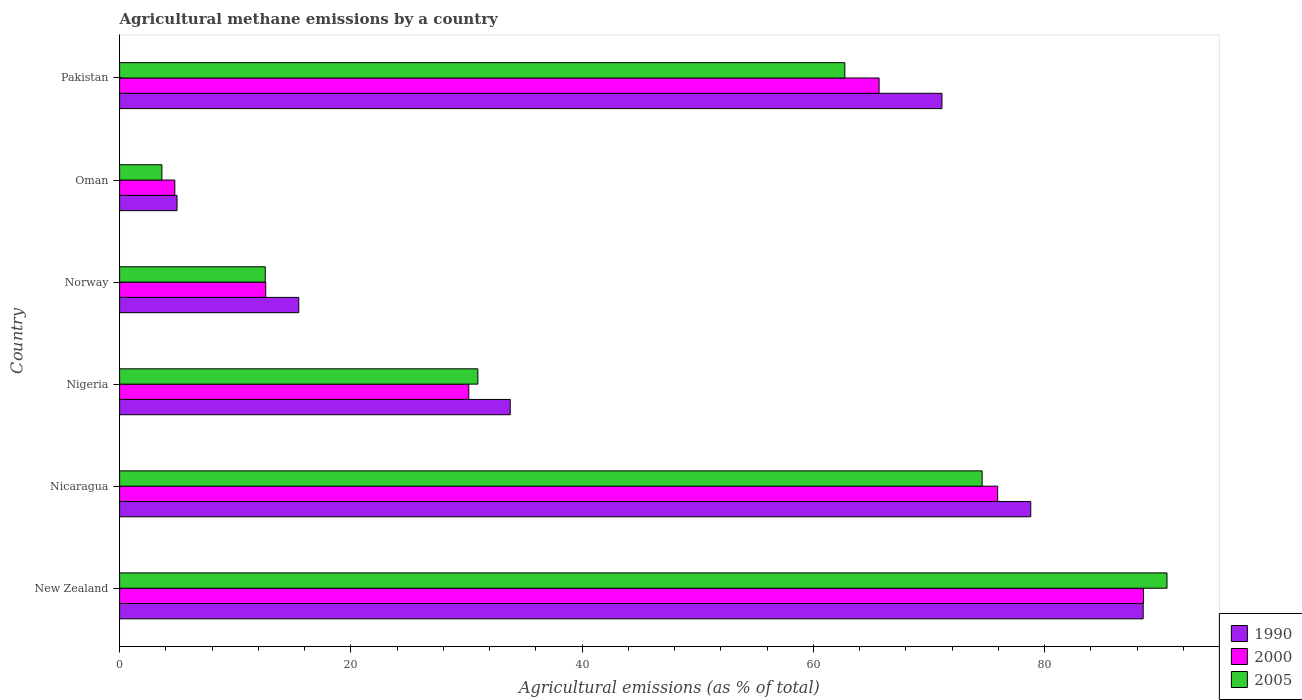How many groups of bars are there?
Offer a very short reply. 6. How many bars are there on the 4th tick from the top?
Give a very brief answer. 3. How many bars are there on the 2nd tick from the bottom?
Provide a succinct answer. 3. What is the label of the 5th group of bars from the top?
Your answer should be very brief. Nicaragua. What is the amount of agricultural methane emitted in 2005 in Oman?
Make the answer very short. 3.66. Across all countries, what is the maximum amount of agricultural methane emitted in 2005?
Make the answer very short. 90.59. Across all countries, what is the minimum amount of agricultural methane emitted in 2005?
Provide a short and direct response. 3.66. In which country was the amount of agricultural methane emitted in 2000 maximum?
Offer a terse response. New Zealand. In which country was the amount of agricultural methane emitted in 2005 minimum?
Keep it short and to the point. Oman. What is the total amount of agricultural methane emitted in 1990 in the graph?
Ensure brevity in your answer.  292.73. What is the difference between the amount of agricultural methane emitted in 2000 in New Zealand and that in Nigeria?
Give a very brief answer. 58.36. What is the difference between the amount of agricultural methane emitted in 2005 in Nicaragua and the amount of agricultural methane emitted in 1990 in Oman?
Your answer should be very brief. 69.64. What is the average amount of agricultural methane emitted in 1990 per country?
Make the answer very short. 48.79. What is the difference between the amount of agricultural methane emitted in 2000 and amount of agricultural methane emitted in 2005 in Nigeria?
Your answer should be very brief. -0.79. What is the ratio of the amount of agricultural methane emitted in 2005 in New Zealand to that in Norway?
Your response must be concise. 7.19. Is the amount of agricultural methane emitted in 1990 in Nicaragua less than that in Nigeria?
Offer a very short reply. No. Is the difference between the amount of agricultural methane emitted in 2000 in Nicaragua and Norway greater than the difference between the amount of agricultural methane emitted in 2005 in Nicaragua and Norway?
Your response must be concise. Yes. What is the difference between the highest and the second highest amount of agricultural methane emitted in 2005?
Provide a succinct answer. 15.99. What is the difference between the highest and the lowest amount of agricultural methane emitted in 2000?
Keep it short and to the point. 83.79. Are the values on the major ticks of X-axis written in scientific E-notation?
Your answer should be very brief. No. Does the graph contain any zero values?
Ensure brevity in your answer.  No. Does the graph contain grids?
Your answer should be very brief. No. Where does the legend appear in the graph?
Your answer should be compact. Bottom right. What is the title of the graph?
Ensure brevity in your answer.  Agricultural methane emissions by a country. What is the label or title of the X-axis?
Provide a succinct answer. Agricultural emissions (as % of total). What is the Agricultural emissions (as % of total) of 1990 in New Zealand?
Give a very brief answer. 88.54. What is the Agricultural emissions (as % of total) of 2000 in New Zealand?
Provide a short and direct response. 88.56. What is the Agricultural emissions (as % of total) of 2005 in New Zealand?
Make the answer very short. 90.59. What is the Agricultural emissions (as % of total) in 1990 in Nicaragua?
Offer a very short reply. 78.81. What is the Agricultural emissions (as % of total) in 2000 in Nicaragua?
Provide a succinct answer. 75.95. What is the Agricultural emissions (as % of total) in 2005 in Nicaragua?
Your answer should be very brief. 74.61. What is the Agricultural emissions (as % of total) of 1990 in Nigeria?
Make the answer very short. 33.79. What is the Agricultural emissions (as % of total) of 2000 in Nigeria?
Your answer should be very brief. 30.2. What is the Agricultural emissions (as % of total) in 2005 in Nigeria?
Your response must be concise. 30.99. What is the Agricultural emissions (as % of total) of 1990 in Norway?
Your answer should be very brief. 15.5. What is the Agricultural emissions (as % of total) of 2000 in Norway?
Ensure brevity in your answer.  12.64. What is the Agricultural emissions (as % of total) in 2005 in Norway?
Offer a terse response. 12.6. What is the Agricultural emissions (as % of total) of 1990 in Oman?
Provide a succinct answer. 4.97. What is the Agricultural emissions (as % of total) in 2000 in Oman?
Your response must be concise. 4.78. What is the Agricultural emissions (as % of total) of 2005 in Oman?
Offer a very short reply. 3.66. What is the Agricultural emissions (as % of total) of 1990 in Pakistan?
Your answer should be compact. 71.13. What is the Agricultural emissions (as % of total) in 2000 in Pakistan?
Your response must be concise. 65.69. What is the Agricultural emissions (as % of total) in 2005 in Pakistan?
Your answer should be compact. 62.73. Across all countries, what is the maximum Agricultural emissions (as % of total) in 1990?
Your answer should be compact. 88.54. Across all countries, what is the maximum Agricultural emissions (as % of total) of 2000?
Make the answer very short. 88.56. Across all countries, what is the maximum Agricultural emissions (as % of total) in 2005?
Offer a terse response. 90.59. Across all countries, what is the minimum Agricultural emissions (as % of total) in 1990?
Make the answer very short. 4.97. Across all countries, what is the minimum Agricultural emissions (as % of total) in 2000?
Provide a succinct answer. 4.78. Across all countries, what is the minimum Agricultural emissions (as % of total) of 2005?
Keep it short and to the point. 3.66. What is the total Agricultural emissions (as % of total) of 1990 in the graph?
Keep it short and to the point. 292.73. What is the total Agricultural emissions (as % of total) in 2000 in the graph?
Offer a terse response. 277.82. What is the total Agricultural emissions (as % of total) in 2005 in the graph?
Make the answer very short. 275.17. What is the difference between the Agricultural emissions (as % of total) of 1990 in New Zealand and that in Nicaragua?
Offer a terse response. 9.72. What is the difference between the Agricultural emissions (as % of total) of 2000 in New Zealand and that in Nicaragua?
Provide a succinct answer. 12.61. What is the difference between the Agricultural emissions (as % of total) of 2005 in New Zealand and that in Nicaragua?
Give a very brief answer. 15.99. What is the difference between the Agricultural emissions (as % of total) of 1990 in New Zealand and that in Nigeria?
Offer a terse response. 54.75. What is the difference between the Agricultural emissions (as % of total) in 2000 in New Zealand and that in Nigeria?
Offer a very short reply. 58.36. What is the difference between the Agricultural emissions (as % of total) of 2005 in New Zealand and that in Nigeria?
Offer a very short reply. 59.61. What is the difference between the Agricultural emissions (as % of total) in 1990 in New Zealand and that in Norway?
Your response must be concise. 73.04. What is the difference between the Agricultural emissions (as % of total) of 2000 in New Zealand and that in Norway?
Give a very brief answer. 75.92. What is the difference between the Agricultural emissions (as % of total) in 2005 in New Zealand and that in Norway?
Your response must be concise. 78. What is the difference between the Agricultural emissions (as % of total) in 1990 in New Zealand and that in Oman?
Keep it short and to the point. 83.57. What is the difference between the Agricultural emissions (as % of total) of 2000 in New Zealand and that in Oman?
Provide a succinct answer. 83.79. What is the difference between the Agricultural emissions (as % of total) in 2005 in New Zealand and that in Oman?
Give a very brief answer. 86.94. What is the difference between the Agricultural emissions (as % of total) in 1990 in New Zealand and that in Pakistan?
Give a very brief answer. 17.4. What is the difference between the Agricultural emissions (as % of total) in 2000 in New Zealand and that in Pakistan?
Give a very brief answer. 22.87. What is the difference between the Agricultural emissions (as % of total) in 2005 in New Zealand and that in Pakistan?
Offer a very short reply. 27.87. What is the difference between the Agricultural emissions (as % of total) of 1990 in Nicaragua and that in Nigeria?
Provide a succinct answer. 45.02. What is the difference between the Agricultural emissions (as % of total) of 2000 in Nicaragua and that in Nigeria?
Your answer should be very brief. 45.75. What is the difference between the Agricultural emissions (as % of total) of 2005 in Nicaragua and that in Nigeria?
Provide a short and direct response. 43.62. What is the difference between the Agricultural emissions (as % of total) of 1990 in Nicaragua and that in Norway?
Provide a short and direct response. 63.31. What is the difference between the Agricultural emissions (as % of total) in 2000 in Nicaragua and that in Norway?
Offer a very short reply. 63.31. What is the difference between the Agricultural emissions (as % of total) of 2005 in Nicaragua and that in Norway?
Your answer should be compact. 62.01. What is the difference between the Agricultural emissions (as % of total) in 1990 in Nicaragua and that in Oman?
Your answer should be very brief. 73.84. What is the difference between the Agricultural emissions (as % of total) of 2000 in Nicaragua and that in Oman?
Provide a short and direct response. 71.17. What is the difference between the Agricultural emissions (as % of total) in 2005 in Nicaragua and that in Oman?
Provide a succinct answer. 70.95. What is the difference between the Agricultural emissions (as % of total) of 1990 in Nicaragua and that in Pakistan?
Your answer should be very brief. 7.68. What is the difference between the Agricultural emissions (as % of total) in 2000 in Nicaragua and that in Pakistan?
Provide a short and direct response. 10.26. What is the difference between the Agricultural emissions (as % of total) in 2005 in Nicaragua and that in Pakistan?
Your response must be concise. 11.88. What is the difference between the Agricultural emissions (as % of total) in 1990 in Nigeria and that in Norway?
Offer a very short reply. 18.29. What is the difference between the Agricultural emissions (as % of total) in 2000 in Nigeria and that in Norway?
Keep it short and to the point. 17.56. What is the difference between the Agricultural emissions (as % of total) in 2005 in Nigeria and that in Norway?
Provide a succinct answer. 18.39. What is the difference between the Agricultural emissions (as % of total) in 1990 in Nigeria and that in Oman?
Ensure brevity in your answer.  28.82. What is the difference between the Agricultural emissions (as % of total) of 2000 in Nigeria and that in Oman?
Offer a very short reply. 25.43. What is the difference between the Agricultural emissions (as % of total) in 2005 in Nigeria and that in Oman?
Your answer should be compact. 27.33. What is the difference between the Agricultural emissions (as % of total) in 1990 in Nigeria and that in Pakistan?
Provide a short and direct response. -37.34. What is the difference between the Agricultural emissions (as % of total) in 2000 in Nigeria and that in Pakistan?
Your answer should be very brief. -35.49. What is the difference between the Agricultural emissions (as % of total) in 2005 in Nigeria and that in Pakistan?
Ensure brevity in your answer.  -31.74. What is the difference between the Agricultural emissions (as % of total) in 1990 in Norway and that in Oman?
Give a very brief answer. 10.53. What is the difference between the Agricultural emissions (as % of total) in 2000 in Norway and that in Oman?
Your answer should be compact. 7.86. What is the difference between the Agricultural emissions (as % of total) in 2005 in Norway and that in Oman?
Ensure brevity in your answer.  8.94. What is the difference between the Agricultural emissions (as % of total) in 1990 in Norway and that in Pakistan?
Give a very brief answer. -55.63. What is the difference between the Agricultural emissions (as % of total) of 2000 in Norway and that in Pakistan?
Provide a short and direct response. -53.05. What is the difference between the Agricultural emissions (as % of total) in 2005 in Norway and that in Pakistan?
Keep it short and to the point. -50.13. What is the difference between the Agricultural emissions (as % of total) of 1990 in Oman and that in Pakistan?
Ensure brevity in your answer.  -66.16. What is the difference between the Agricultural emissions (as % of total) in 2000 in Oman and that in Pakistan?
Offer a terse response. -60.92. What is the difference between the Agricultural emissions (as % of total) in 2005 in Oman and that in Pakistan?
Your response must be concise. -59.07. What is the difference between the Agricultural emissions (as % of total) in 1990 in New Zealand and the Agricultural emissions (as % of total) in 2000 in Nicaragua?
Provide a short and direct response. 12.59. What is the difference between the Agricultural emissions (as % of total) in 1990 in New Zealand and the Agricultural emissions (as % of total) in 2005 in Nicaragua?
Your response must be concise. 13.93. What is the difference between the Agricultural emissions (as % of total) of 2000 in New Zealand and the Agricultural emissions (as % of total) of 2005 in Nicaragua?
Provide a short and direct response. 13.95. What is the difference between the Agricultural emissions (as % of total) of 1990 in New Zealand and the Agricultural emissions (as % of total) of 2000 in Nigeria?
Your answer should be compact. 58.33. What is the difference between the Agricultural emissions (as % of total) of 1990 in New Zealand and the Agricultural emissions (as % of total) of 2005 in Nigeria?
Keep it short and to the point. 57.55. What is the difference between the Agricultural emissions (as % of total) in 2000 in New Zealand and the Agricultural emissions (as % of total) in 2005 in Nigeria?
Give a very brief answer. 57.57. What is the difference between the Agricultural emissions (as % of total) of 1990 in New Zealand and the Agricultural emissions (as % of total) of 2000 in Norway?
Offer a terse response. 75.9. What is the difference between the Agricultural emissions (as % of total) of 1990 in New Zealand and the Agricultural emissions (as % of total) of 2005 in Norway?
Ensure brevity in your answer.  75.94. What is the difference between the Agricultural emissions (as % of total) of 2000 in New Zealand and the Agricultural emissions (as % of total) of 2005 in Norway?
Your answer should be very brief. 75.96. What is the difference between the Agricultural emissions (as % of total) of 1990 in New Zealand and the Agricultural emissions (as % of total) of 2000 in Oman?
Provide a short and direct response. 83.76. What is the difference between the Agricultural emissions (as % of total) of 1990 in New Zealand and the Agricultural emissions (as % of total) of 2005 in Oman?
Your response must be concise. 84.88. What is the difference between the Agricultural emissions (as % of total) of 2000 in New Zealand and the Agricultural emissions (as % of total) of 2005 in Oman?
Your answer should be very brief. 84.91. What is the difference between the Agricultural emissions (as % of total) of 1990 in New Zealand and the Agricultural emissions (as % of total) of 2000 in Pakistan?
Offer a terse response. 22.84. What is the difference between the Agricultural emissions (as % of total) in 1990 in New Zealand and the Agricultural emissions (as % of total) in 2005 in Pakistan?
Provide a succinct answer. 25.81. What is the difference between the Agricultural emissions (as % of total) of 2000 in New Zealand and the Agricultural emissions (as % of total) of 2005 in Pakistan?
Keep it short and to the point. 25.83. What is the difference between the Agricultural emissions (as % of total) in 1990 in Nicaragua and the Agricultural emissions (as % of total) in 2000 in Nigeria?
Make the answer very short. 48.61. What is the difference between the Agricultural emissions (as % of total) in 1990 in Nicaragua and the Agricultural emissions (as % of total) in 2005 in Nigeria?
Ensure brevity in your answer.  47.82. What is the difference between the Agricultural emissions (as % of total) of 2000 in Nicaragua and the Agricultural emissions (as % of total) of 2005 in Nigeria?
Ensure brevity in your answer.  44.96. What is the difference between the Agricultural emissions (as % of total) of 1990 in Nicaragua and the Agricultural emissions (as % of total) of 2000 in Norway?
Provide a short and direct response. 66.17. What is the difference between the Agricultural emissions (as % of total) of 1990 in Nicaragua and the Agricultural emissions (as % of total) of 2005 in Norway?
Provide a succinct answer. 66.21. What is the difference between the Agricultural emissions (as % of total) in 2000 in Nicaragua and the Agricultural emissions (as % of total) in 2005 in Norway?
Offer a very short reply. 63.35. What is the difference between the Agricultural emissions (as % of total) in 1990 in Nicaragua and the Agricultural emissions (as % of total) in 2000 in Oman?
Give a very brief answer. 74.03. What is the difference between the Agricultural emissions (as % of total) of 1990 in Nicaragua and the Agricultural emissions (as % of total) of 2005 in Oman?
Offer a terse response. 75.15. What is the difference between the Agricultural emissions (as % of total) in 2000 in Nicaragua and the Agricultural emissions (as % of total) in 2005 in Oman?
Ensure brevity in your answer.  72.29. What is the difference between the Agricultural emissions (as % of total) of 1990 in Nicaragua and the Agricultural emissions (as % of total) of 2000 in Pakistan?
Your response must be concise. 13.12. What is the difference between the Agricultural emissions (as % of total) in 1990 in Nicaragua and the Agricultural emissions (as % of total) in 2005 in Pakistan?
Provide a succinct answer. 16.08. What is the difference between the Agricultural emissions (as % of total) of 2000 in Nicaragua and the Agricultural emissions (as % of total) of 2005 in Pakistan?
Make the answer very short. 13.22. What is the difference between the Agricultural emissions (as % of total) in 1990 in Nigeria and the Agricultural emissions (as % of total) in 2000 in Norway?
Make the answer very short. 21.15. What is the difference between the Agricultural emissions (as % of total) in 1990 in Nigeria and the Agricultural emissions (as % of total) in 2005 in Norway?
Your answer should be compact. 21.19. What is the difference between the Agricultural emissions (as % of total) of 2000 in Nigeria and the Agricultural emissions (as % of total) of 2005 in Norway?
Provide a short and direct response. 17.6. What is the difference between the Agricultural emissions (as % of total) of 1990 in Nigeria and the Agricultural emissions (as % of total) of 2000 in Oman?
Offer a very short reply. 29.01. What is the difference between the Agricultural emissions (as % of total) in 1990 in Nigeria and the Agricultural emissions (as % of total) in 2005 in Oman?
Provide a succinct answer. 30.13. What is the difference between the Agricultural emissions (as % of total) of 2000 in Nigeria and the Agricultural emissions (as % of total) of 2005 in Oman?
Your answer should be compact. 26.55. What is the difference between the Agricultural emissions (as % of total) in 1990 in Nigeria and the Agricultural emissions (as % of total) in 2000 in Pakistan?
Ensure brevity in your answer.  -31.91. What is the difference between the Agricultural emissions (as % of total) of 1990 in Nigeria and the Agricultural emissions (as % of total) of 2005 in Pakistan?
Give a very brief answer. -28.94. What is the difference between the Agricultural emissions (as % of total) in 2000 in Nigeria and the Agricultural emissions (as % of total) in 2005 in Pakistan?
Make the answer very short. -32.53. What is the difference between the Agricultural emissions (as % of total) in 1990 in Norway and the Agricultural emissions (as % of total) in 2000 in Oman?
Keep it short and to the point. 10.72. What is the difference between the Agricultural emissions (as % of total) in 1990 in Norway and the Agricultural emissions (as % of total) in 2005 in Oman?
Give a very brief answer. 11.84. What is the difference between the Agricultural emissions (as % of total) in 2000 in Norway and the Agricultural emissions (as % of total) in 2005 in Oman?
Give a very brief answer. 8.98. What is the difference between the Agricultural emissions (as % of total) in 1990 in Norway and the Agricultural emissions (as % of total) in 2000 in Pakistan?
Make the answer very short. -50.2. What is the difference between the Agricultural emissions (as % of total) in 1990 in Norway and the Agricultural emissions (as % of total) in 2005 in Pakistan?
Provide a succinct answer. -47.23. What is the difference between the Agricultural emissions (as % of total) of 2000 in Norway and the Agricultural emissions (as % of total) of 2005 in Pakistan?
Provide a succinct answer. -50.09. What is the difference between the Agricultural emissions (as % of total) in 1990 in Oman and the Agricultural emissions (as % of total) in 2000 in Pakistan?
Offer a very short reply. -60.73. What is the difference between the Agricultural emissions (as % of total) of 1990 in Oman and the Agricultural emissions (as % of total) of 2005 in Pakistan?
Your answer should be very brief. -57.76. What is the difference between the Agricultural emissions (as % of total) in 2000 in Oman and the Agricultural emissions (as % of total) in 2005 in Pakistan?
Offer a very short reply. -57.95. What is the average Agricultural emissions (as % of total) of 1990 per country?
Your answer should be very brief. 48.79. What is the average Agricultural emissions (as % of total) of 2000 per country?
Ensure brevity in your answer.  46.3. What is the average Agricultural emissions (as % of total) of 2005 per country?
Ensure brevity in your answer.  45.86. What is the difference between the Agricultural emissions (as % of total) of 1990 and Agricultural emissions (as % of total) of 2000 in New Zealand?
Ensure brevity in your answer.  -0.03. What is the difference between the Agricultural emissions (as % of total) of 1990 and Agricultural emissions (as % of total) of 2005 in New Zealand?
Offer a very short reply. -2.06. What is the difference between the Agricultural emissions (as % of total) of 2000 and Agricultural emissions (as % of total) of 2005 in New Zealand?
Provide a short and direct response. -2.03. What is the difference between the Agricultural emissions (as % of total) of 1990 and Agricultural emissions (as % of total) of 2000 in Nicaragua?
Your answer should be compact. 2.86. What is the difference between the Agricultural emissions (as % of total) in 1990 and Agricultural emissions (as % of total) in 2005 in Nicaragua?
Ensure brevity in your answer.  4.2. What is the difference between the Agricultural emissions (as % of total) of 2000 and Agricultural emissions (as % of total) of 2005 in Nicaragua?
Your answer should be very brief. 1.34. What is the difference between the Agricultural emissions (as % of total) of 1990 and Agricultural emissions (as % of total) of 2000 in Nigeria?
Your response must be concise. 3.58. What is the difference between the Agricultural emissions (as % of total) in 1990 and Agricultural emissions (as % of total) in 2005 in Nigeria?
Your answer should be very brief. 2.8. What is the difference between the Agricultural emissions (as % of total) in 2000 and Agricultural emissions (as % of total) in 2005 in Nigeria?
Your answer should be compact. -0.79. What is the difference between the Agricultural emissions (as % of total) of 1990 and Agricultural emissions (as % of total) of 2000 in Norway?
Your answer should be compact. 2.86. What is the difference between the Agricultural emissions (as % of total) of 1990 and Agricultural emissions (as % of total) of 2005 in Norway?
Provide a succinct answer. 2.9. What is the difference between the Agricultural emissions (as % of total) of 2000 and Agricultural emissions (as % of total) of 2005 in Norway?
Keep it short and to the point. 0.04. What is the difference between the Agricultural emissions (as % of total) of 1990 and Agricultural emissions (as % of total) of 2000 in Oman?
Give a very brief answer. 0.19. What is the difference between the Agricultural emissions (as % of total) in 1990 and Agricultural emissions (as % of total) in 2005 in Oman?
Your answer should be very brief. 1.31. What is the difference between the Agricultural emissions (as % of total) of 2000 and Agricultural emissions (as % of total) of 2005 in Oman?
Your answer should be very brief. 1.12. What is the difference between the Agricultural emissions (as % of total) of 1990 and Agricultural emissions (as % of total) of 2000 in Pakistan?
Keep it short and to the point. 5.44. What is the difference between the Agricultural emissions (as % of total) in 1990 and Agricultural emissions (as % of total) in 2005 in Pakistan?
Offer a terse response. 8.4. What is the difference between the Agricultural emissions (as % of total) of 2000 and Agricultural emissions (as % of total) of 2005 in Pakistan?
Keep it short and to the point. 2.96. What is the ratio of the Agricultural emissions (as % of total) of 1990 in New Zealand to that in Nicaragua?
Your answer should be compact. 1.12. What is the ratio of the Agricultural emissions (as % of total) of 2000 in New Zealand to that in Nicaragua?
Your response must be concise. 1.17. What is the ratio of the Agricultural emissions (as % of total) in 2005 in New Zealand to that in Nicaragua?
Your response must be concise. 1.21. What is the ratio of the Agricultural emissions (as % of total) in 1990 in New Zealand to that in Nigeria?
Your answer should be compact. 2.62. What is the ratio of the Agricultural emissions (as % of total) in 2000 in New Zealand to that in Nigeria?
Provide a short and direct response. 2.93. What is the ratio of the Agricultural emissions (as % of total) of 2005 in New Zealand to that in Nigeria?
Provide a short and direct response. 2.92. What is the ratio of the Agricultural emissions (as % of total) of 1990 in New Zealand to that in Norway?
Keep it short and to the point. 5.71. What is the ratio of the Agricultural emissions (as % of total) of 2000 in New Zealand to that in Norway?
Provide a succinct answer. 7.01. What is the ratio of the Agricultural emissions (as % of total) of 2005 in New Zealand to that in Norway?
Make the answer very short. 7.19. What is the ratio of the Agricultural emissions (as % of total) of 1990 in New Zealand to that in Oman?
Offer a very short reply. 17.83. What is the ratio of the Agricultural emissions (as % of total) of 2000 in New Zealand to that in Oman?
Offer a very short reply. 18.54. What is the ratio of the Agricultural emissions (as % of total) in 2005 in New Zealand to that in Oman?
Your answer should be compact. 24.78. What is the ratio of the Agricultural emissions (as % of total) of 1990 in New Zealand to that in Pakistan?
Keep it short and to the point. 1.24. What is the ratio of the Agricultural emissions (as % of total) of 2000 in New Zealand to that in Pakistan?
Your answer should be compact. 1.35. What is the ratio of the Agricultural emissions (as % of total) in 2005 in New Zealand to that in Pakistan?
Your answer should be very brief. 1.44. What is the ratio of the Agricultural emissions (as % of total) in 1990 in Nicaragua to that in Nigeria?
Provide a short and direct response. 2.33. What is the ratio of the Agricultural emissions (as % of total) of 2000 in Nicaragua to that in Nigeria?
Keep it short and to the point. 2.51. What is the ratio of the Agricultural emissions (as % of total) in 2005 in Nicaragua to that in Nigeria?
Give a very brief answer. 2.41. What is the ratio of the Agricultural emissions (as % of total) of 1990 in Nicaragua to that in Norway?
Provide a succinct answer. 5.09. What is the ratio of the Agricultural emissions (as % of total) of 2000 in Nicaragua to that in Norway?
Provide a succinct answer. 6.01. What is the ratio of the Agricultural emissions (as % of total) in 2005 in Nicaragua to that in Norway?
Your answer should be compact. 5.92. What is the ratio of the Agricultural emissions (as % of total) of 1990 in Nicaragua to that in Oman?
Give a very brief answer. 15.87. What is the ratio of the Agricultural emissions (as % of total) in 2000 in Nicaragua to that in Oman?
Provide a succinct answer. 15.9. What is the ratio of the Agricultural emissions (as % of total) in 2005 in Nicaragua to that in Oman?
Your response must be concise. 20.41. What is the ratio of the Agricultural emissions (as % of total) of 1990 in Nicaragua to that in Pakistan?
Your answer should be very brief. 1.11. What is the ratio of the Agricultural emissions (as % of total) of 2000 in Nicaragua to that in Pakistan?
Keep it short and to the point. 1.16. What is the ratio of the Agricultural emissions (as % of total) in 2005 in Nicaragua to that in Pakistan?
Give a very brief answer. 1.19. What is the ratio of the Agricultural emissions (as % of total) of 1990 in Nigeria to that in Norway?
Your response must be concise. 2.18. What is the ratio of the Agricultural emissions (as % of total) in 2000 in Nigeria to that in Norway?
Make the answer very short. 2.39. What is the ratio of the Agricultural emissions (as % of total) of 2005 in Nigeria to that in Norway?
Keep it short and to the point. 2.46. What is the ratio of the Agricultural emissions (as % of total) in 1990 in Nigeria to that in Oman?
Provide a succinct answer. 6.8. What is the ratio of the Agricultural emissions (as % of total) of 2000 in Nigeria to that in Oman?
Provide a short and direct response. 6.32. What is the ratio of the Agricultural emissions (as % of total) in 2005 in Nigeria to that in Oman?
Provide a short and direct response. 8.48. What is the ratio of the Agricultural emissions (as % of total) in 1990 in Nigeria to that in Pakistan?
Ensure brevity in your answer.  0.47. What is the ratio of the Agricultural emissions (as % of total) of 2000 in Nigeria to that in Pakistan?
Keep it short and to the point. 0.46. What is the ratio of the Agricultural emissions (as % of total) in 2005 in Nigeria to that in Pakistan?
Make the answer very short. 0.49. What is the ratio of the Agricultural emissions (as % of total) in 1990 in Norway to that in Oman?
Your response must be concise. 3.12. What is the ratio of the Agricultural emissions (as % of total) in 2000 in Norway to that in Oman?
Your response must be concise. 2.65. What is the ratio of the Agricultural emissions (as % of total) of 2005 in Norway to that in Oman?
Provide a short and direct response. 3.45. What is the ratio of the Agricultural emissions (as % of total) in 1990 in Norway to that in Pakistan?
Ensure brevity in your answer.  0.22. What is the ratio of the Agricultural emissions (as % of total) in 2000 in Norway to that in Pakistan?
Provide a short and direct response. 0.19. What is the ratio of the Agricultural emissions (as % of total) of 2005 in Norway to that in Pakistan?
Ensure brevity in your answer.  0.2. What is the ratio of the Agricultural emissions (as % of total) in 1990 in Oman to that in Pakistan?
Give a very brief answer. 0.07. What is the ratio of the Agricultural emissions (as % of total) of 2000 in Oman to that in Pakistan?
Make the answer very short. 0.07. What is the ratio of the Agricultural emissions (as % of total) of 2005 in Oman to that in Pakistan?
Ensure brevity in your answer.  0.06. What is the difference between the highest and the second highest Agricultural emissions (as % of total) in 1990?
Ensure brevity in your answer.  9.72. What is the difference between the highest and the second highest Agricultural emissions (as % of total) in 2000?
Keep it short and to the point. 12.61. What is the difference between the highest and the second highest Agricultural emissions (as % of total) of 2005?
Make the answer very short. 15.99. What is the difference between the highest and the lowest Agricultural emissions (as % of total) in 1990?
Provide a succinct answer. 83.57. What is the difference between the highest and the lowest Agricultural emissions (as % of total) in 2000?
Your answer should be compact. 83.79. What is the difference between the highest and the lowest Agricultural emissions (as % of total) of 2005?
Provide a succinct answer. 86.94. 